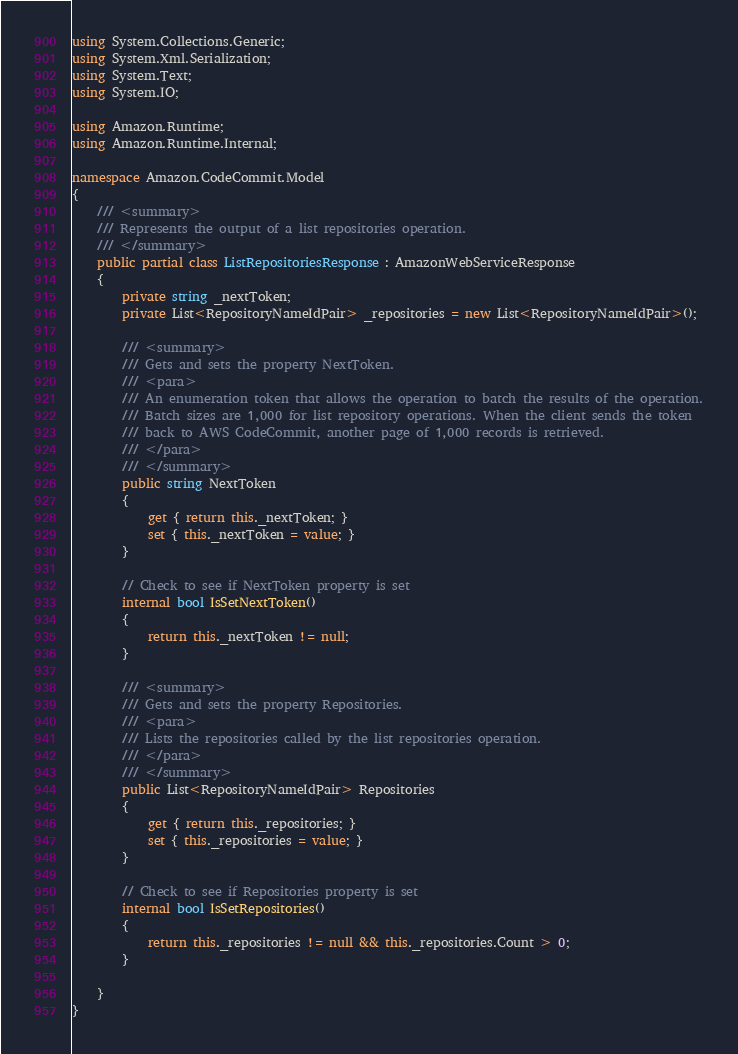<code> <loc_0><loc_0><loc_500><loc_500><_C#_>using System.Collections.Generic;
using System.Xml.Serialization;
using System.Text;
using System.IO;

using Amazon.Runtime;
using Amazon.Runtime.Internal;

namespace Amazon.CodeCommit.Model
{
    /// <summary>
    /// Represents the output of a list repositories operation.
    /// </summary>
    public partial class ListRepositoriesResponse : AmazonWebServiceResponse
    {
        private string _nextToken;
        private List<RepositoryNameIdPair> _repositories = new List<RepositoryNameIdPair>();

        /// <summary>
        /// Gets and sets the property NextToken. 
        /// <para>
        /// An enumeration token that allows the operation to batch the results of the operation.
        /// Batch sizes are 1,000 for list repository operations. When the client sends the token
        /// back to AWS CodeCommit, another page of 1,000 records is retrieved.
        /// </para>
        /// </summary>
        public string NextToken
        {
            get { return this._nextToken; }
            set { this._nextToken = value; }
        }

        // Check to see if NextToken property is set
        internal bool IsSetNextToken()
        {
            return this._nextToken != null;
        }

        /// <summary>
        /// Gets and sets the property Repositories. 
        /// <para>
        /// Lists the repositories called by the list repositories operation.
        /// </para>
        /// </summary>
        public List<RepositoryNameIdPair> Repositories
        {
            get { return this._repositories; }
            set { this._repositories = value; }
        }

        // Check to see if Repositories property is set
        internal bool IsSetRepositories()
        {
            return this._repositories != null && this._repositories.Count > 0; 
        }

    }
}</code> 